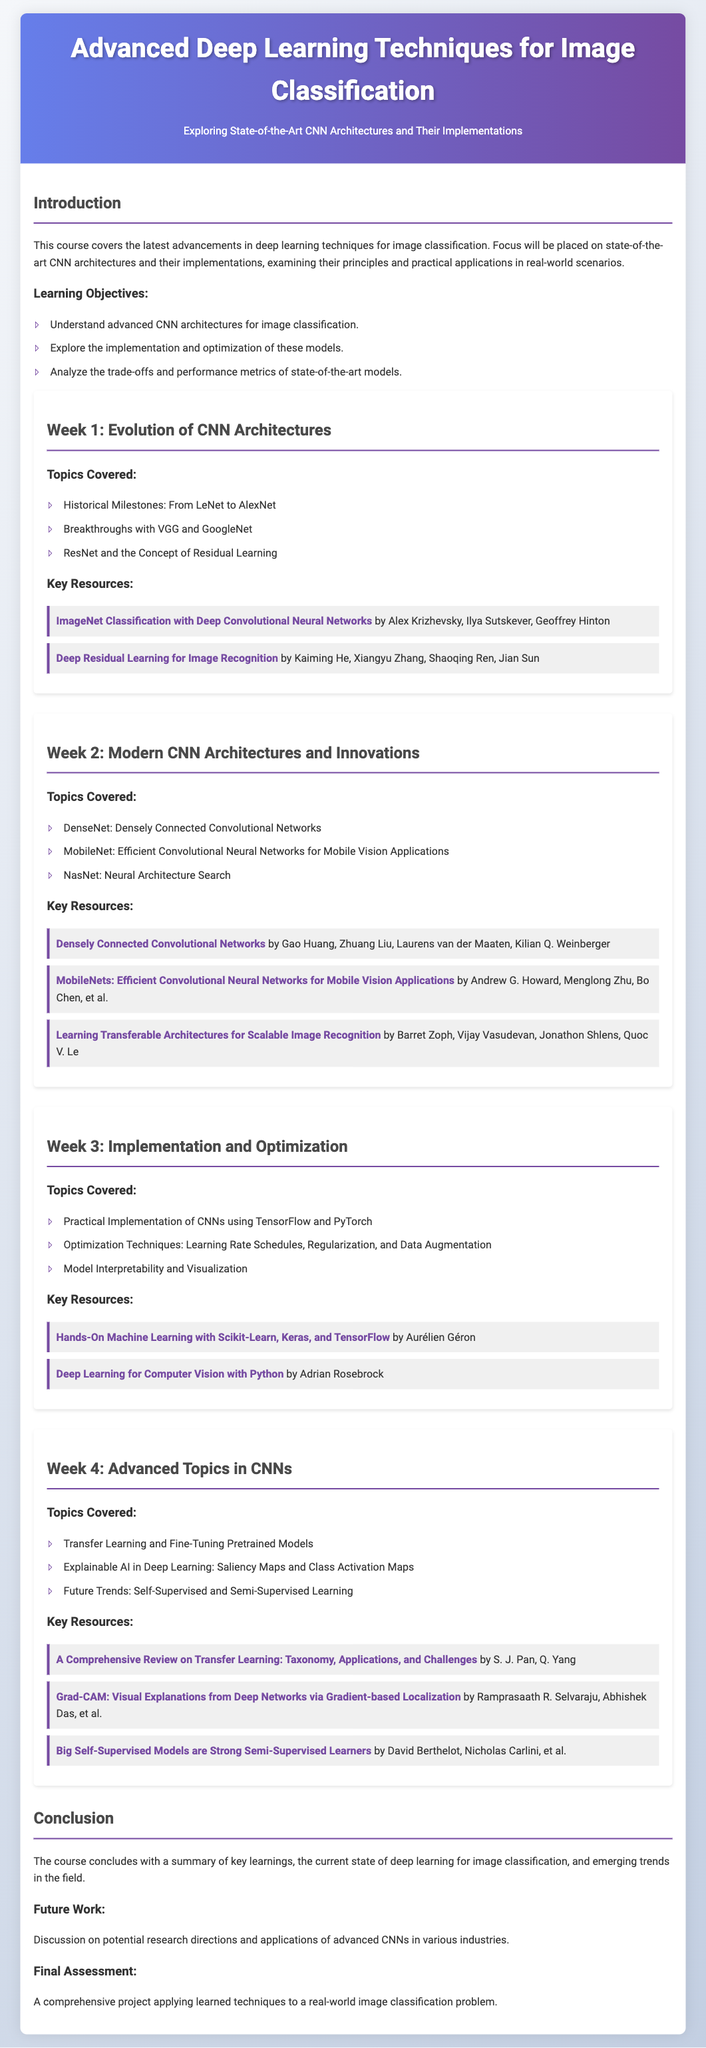What is the title of the course? The title of the course is displayed prominently at the top of the document, stating "Advanced Deep Learning Techniques for Image Classification."
Answer: Advanced Deep Learning Techniques for Image Classification What is covered in Week 1? The document lists the topics covered in Week 1 under the heading "Week 1: Evolution of CNN Architectures," which includes historical milestones and concepts like Residual Learning.
Answer: Evolution of CNN Architectures Who are the authors of the resource on AlexNet? The document provides a specific resource that mentions the authors, "ImageNet Classification with Deep Convolutional Neural Networks," which includes Alex Krizhevsky, Ilya Sutskever, Geoffrey Hinton.
Answer: Alex Krizhevsky, Ilya Sutskever, Geoffrey Hinton What is the focus of Week 3? The title of Week 3 indicates that the focus is on "Implementation and Optimization," discussing practical implementation and various optimization techniques.
Answer: Implementation and Optimization What is one topic discussed in Week 4? The document outlines several topics under "Week 4: Advanced Topics in CNNs," including "Transfer Learning and Fine-Tuning Pretrained Models."
Answer: Transfer Learning and Fine-Tuning Pretrained Models What is the key objective of the course? The learning objectives listed in the introduction include understanding advanced CNN architectures, which indicates the key objective of the course.
Answer: Understand advanced CNN architectures What is the final assessment of the course? The conclusion section specifies that the final assessment consists of a comprehensive project applying learned techniques.
Answer: A comprehensive project Which frameworks are mentioned for practical implementation? In Week 3, it specifically states that TensorFlow and PyTorch are mentioned for practical implementation of CNNs.
Answer: TensorFlow and PyTorch How many weeks is the syllabus structured into? The document lays out four weeks, indicating the total structure of the syllabus.
Answer: 4 weeks 